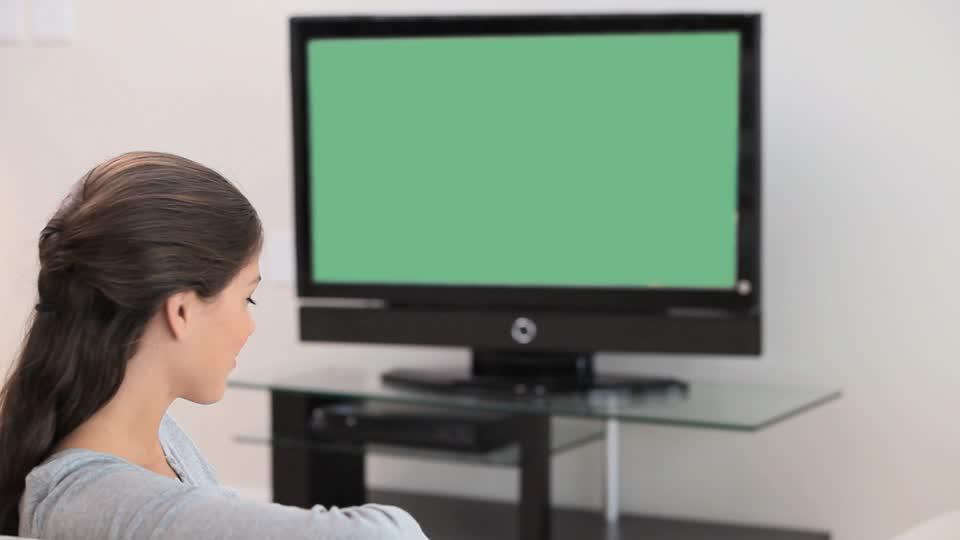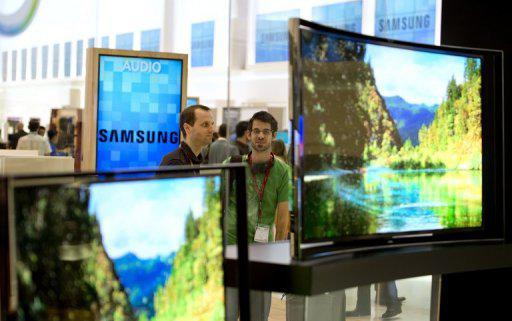The first image is the image on the left, the second image is the image on the right. Examine the images to the left and right. Is the description "In the right image, a girl sitting on her knees in front of a TV screen has her head turned to look over her shoulder." accurate? Answer yes or no. No. The first image is the image on the left, the second image is the image on the right. For the images displayed, is the sentence "One of the TVs has a blank green screen." factually correct? Answer yes or no. Yes. 